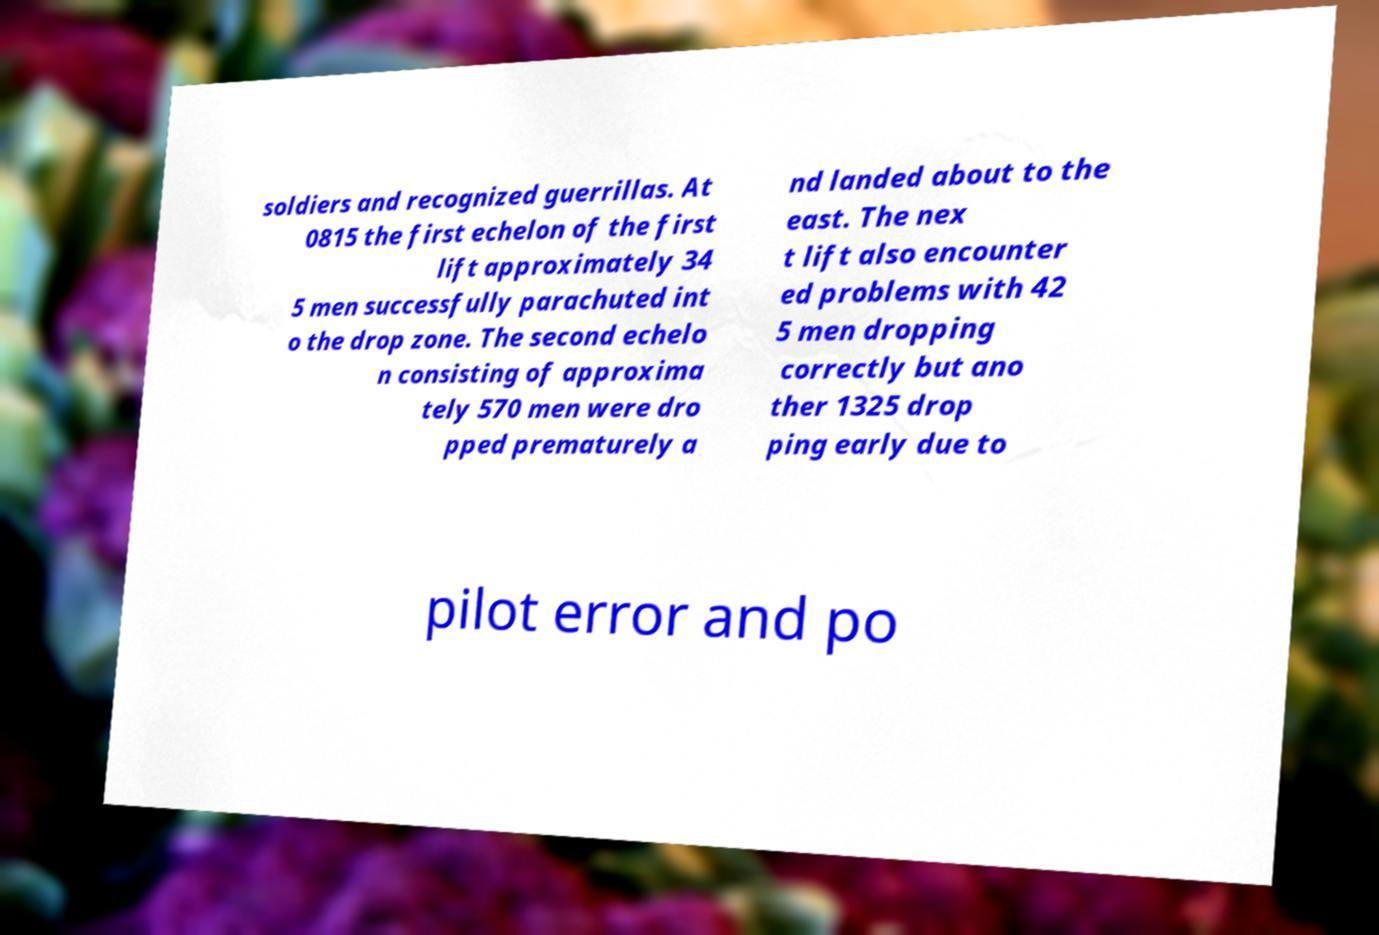Could you extract and type out the text from this image? soldiers and recognized guerrillas. At 0815 the first echelon of the first lift approximately 34 5 men successfully parachuted int o the drop zone. The second echelo n consisting of approxima tely 570 men were dro pped prematurely a nd landed about to the east. The nex t lift also encounter ed problems with 42 5 men dropping correctly but ano ther 1325 drop ping early due to pilot error and po 